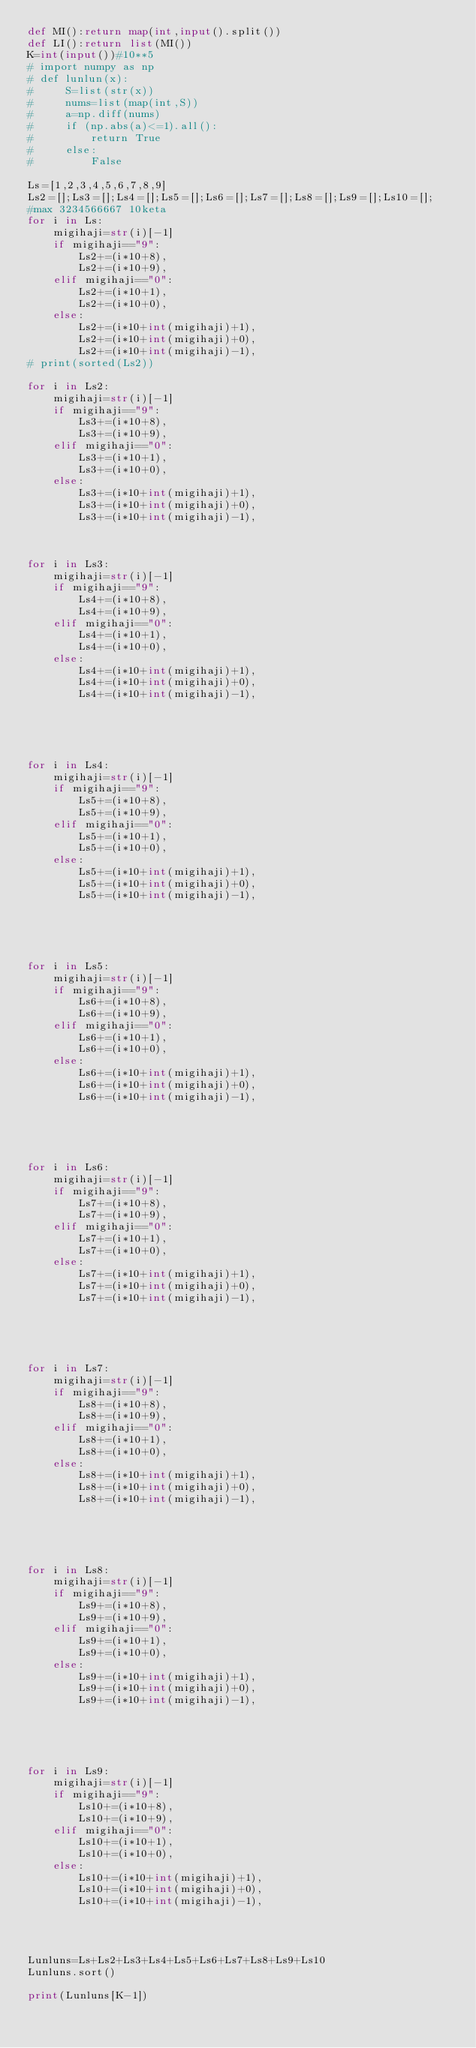<code> <loc_0><loc_0><loc_500><loc_500><_Python_>def MI():return map(int,input().split())
def LI():return list(MI())
K=int(input())#10**5
# import numpy as np
# def lunlun(x):
#     S=list(str(x))
#     nums=list(map(int,S))
#     a=np.diff(nums)
#     if (np.abs(a)<=1).all():
#         return True
#     else:
#         False

Ls=[1,2,3,4,5,6,7,8,9]
Ls2=[];Ls3=[];Ls4=[];Ls5=[];Ls6=[];Ls7=[];Ls8=[];Ls9=[];Ls10=[];
#max 3234566667 10keta
for i in Ls:
    migihaji=str(i)[-1]
    if migihaji=="9":
        Ls2+=(i*10+8),
        Ls2+=(i*10+9),
    elif migihaji=="0":
        Ls2+=(i*10+1),
        Ls2+=(i*10+0),
    else:
        Ls2+=(i*10+int(migihaji)+1),
        Ls2+=(i*10+int(migihaji)+0),
        Ls2+=(i*10+int(migihaji)-1),
# print(sorted(Ls2))

for i in Ls2:
    migihaji=str(i)[-1]
    if migihaji=="9":
        Ls3+=(i*10+8),
        Ls3+=(i*10+9),
    elif migihaji=="0":
        Ls3+=(i*10+1),
        Ls3+=(i*10+0),
    else:
        Ls3+=(i*10+int(migihaji)+1),
        Ls3+=(i*10+int(migihaji)+0),
        Ls3+=(i*10+int(migihaji)-1),



for i in Ls3:
    migihaji=str(i)[-1]
    if migihaji=="9":
        Ls4+=(i*10+8),
        Ls4+=(i*10+9),
    elif migihaji=="0":
        Ls4+=(i*10+1),
        Ls4+=(i*10+0),
    else:
        Ls4+=(i*10+int(migihaji)+1),
        Ls4+=(i*10+int(migihaji)+0),
        Ls4+=(i*10+int(migihaji)-1),





for i in Ls4:
    migihaji=str(i)[-1]
    if migihaji=="9":
        Ls5+=(i*10+8),
        Ls5+=(i*10+9),
    elif migihaji=="0":
        Ls5+=(i*10+1),
        Ls5+=(i*10+0),
    else:
        Ls5+=(i*10+int(migihaji)+1),
        Ls5+=(i*10+int(migihaji)+0),
        Ls5+=(i*10+int(migihaji)-1),





for i in Ls5:
    migihaji=str(i)[-1]
    if migihaji=="9":
        Ls6+=(i*10+8),
        Ls6+=(i*10+9),
    elif migihaji=="0":
        Ls6+=(i*10+1),
        Ls6+=(i*10+0),
    else:
        Ls6+=(i*10+int(migihaji)+1),
        Ls6+=(i*10+int(migihaji)+0),
        Ls6+=(i*10+int(migihaji)-1),





for i in Ls6:
    migihaji=str(i)[-1]
    if migihaji=="9":
        Ls7+=(i*10+8),
        Ls7+=(i*10+9),
    elif migihaji=="0":
        Ls7+=(i*10+1),
        Ls7+=(i*10+0),
    else:
        Ls7+=(i*10+int(migihaji)+1),
        Ls7+=(i*10+int(migihaji)+0),
        Ls7+=(i*10+int(migihaji)-1),





for i in Ls7:
    migihaji=str(i)[-1]
    if migihaji=="9":
        Ls8+=(i*10+8),
        Ls8+=(i*10+9),
    elif migihaji=="0":
        Ls8+=(i*10+1),
        Ls8+=(i*10+0),
    else:
        Ls8+=(i*10+int(migihaji)+1),
        Ls8+=(i*10+int(migihaji)+0),
        Ls8+=(i*10+int(migihaji)-1),





for i in Ls8:
    migihaji=str(i)[-1]
    if migihaji=="9":
        Ls9+=(i*10+8),
        Ls9+=(i*10+9),
    elif migihaji=="0":
        Ls9+=(i*10+1),
        Ls9+=(i*10+0),
    else:
        Ls9+=(i*10+int(migihaji)+1),
        Ls9+=(i*10+int(migihaji)+0),
        Ls9+=(i*10+int(migihaji)-1),





for i in Ls9:
    migihaji=str(i)[-1]
    if migihaji=="9":
        Ls10+=(i*10+8),
        Ls10+=(i*10+9),
    elif migihaji=="0":
        Ls10+=(i*10+1),
        Ls10+=(i*10+0),
    else:
        Ls10+=(i*10+int(migihaji)+1),
        Ls10+=(i*10+int(migihaji)+0),
        Ls10+=(i*10+int(migihaji)-1),




Lunluns=Ls+Ls2+Ls3+Ls4+Ls5+Ls6+Ls7+Ls8+Ls9+Ls10
Lunluns.sort()

print(Lunluns[K-1])</code> 